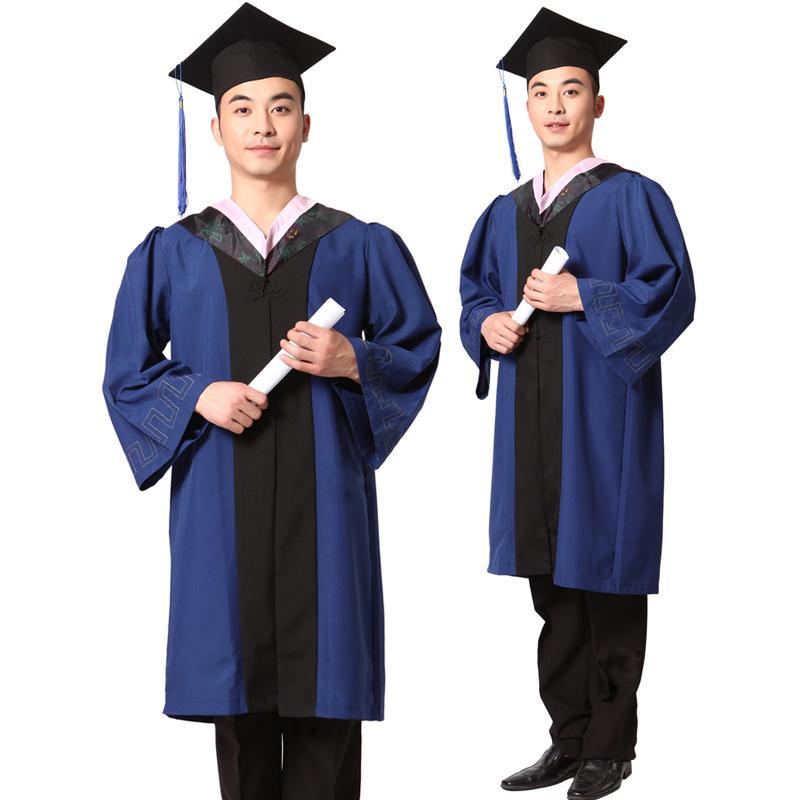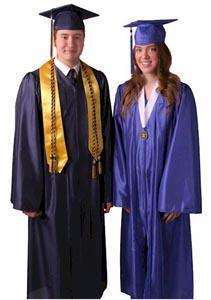The first image is the image on the left, the second image is the image on the right. Given the left and right images, does the statement "One image shows the same male graduate in multiple poses, and the other image includes a female graduate." hold true? Answer yes or no. Yes. The first image is the image on the left, the second image is the image on the right. For the images shown, is this caption "Three people are modeling graduation attire in one of the images." true? Answer yes or no. No. 